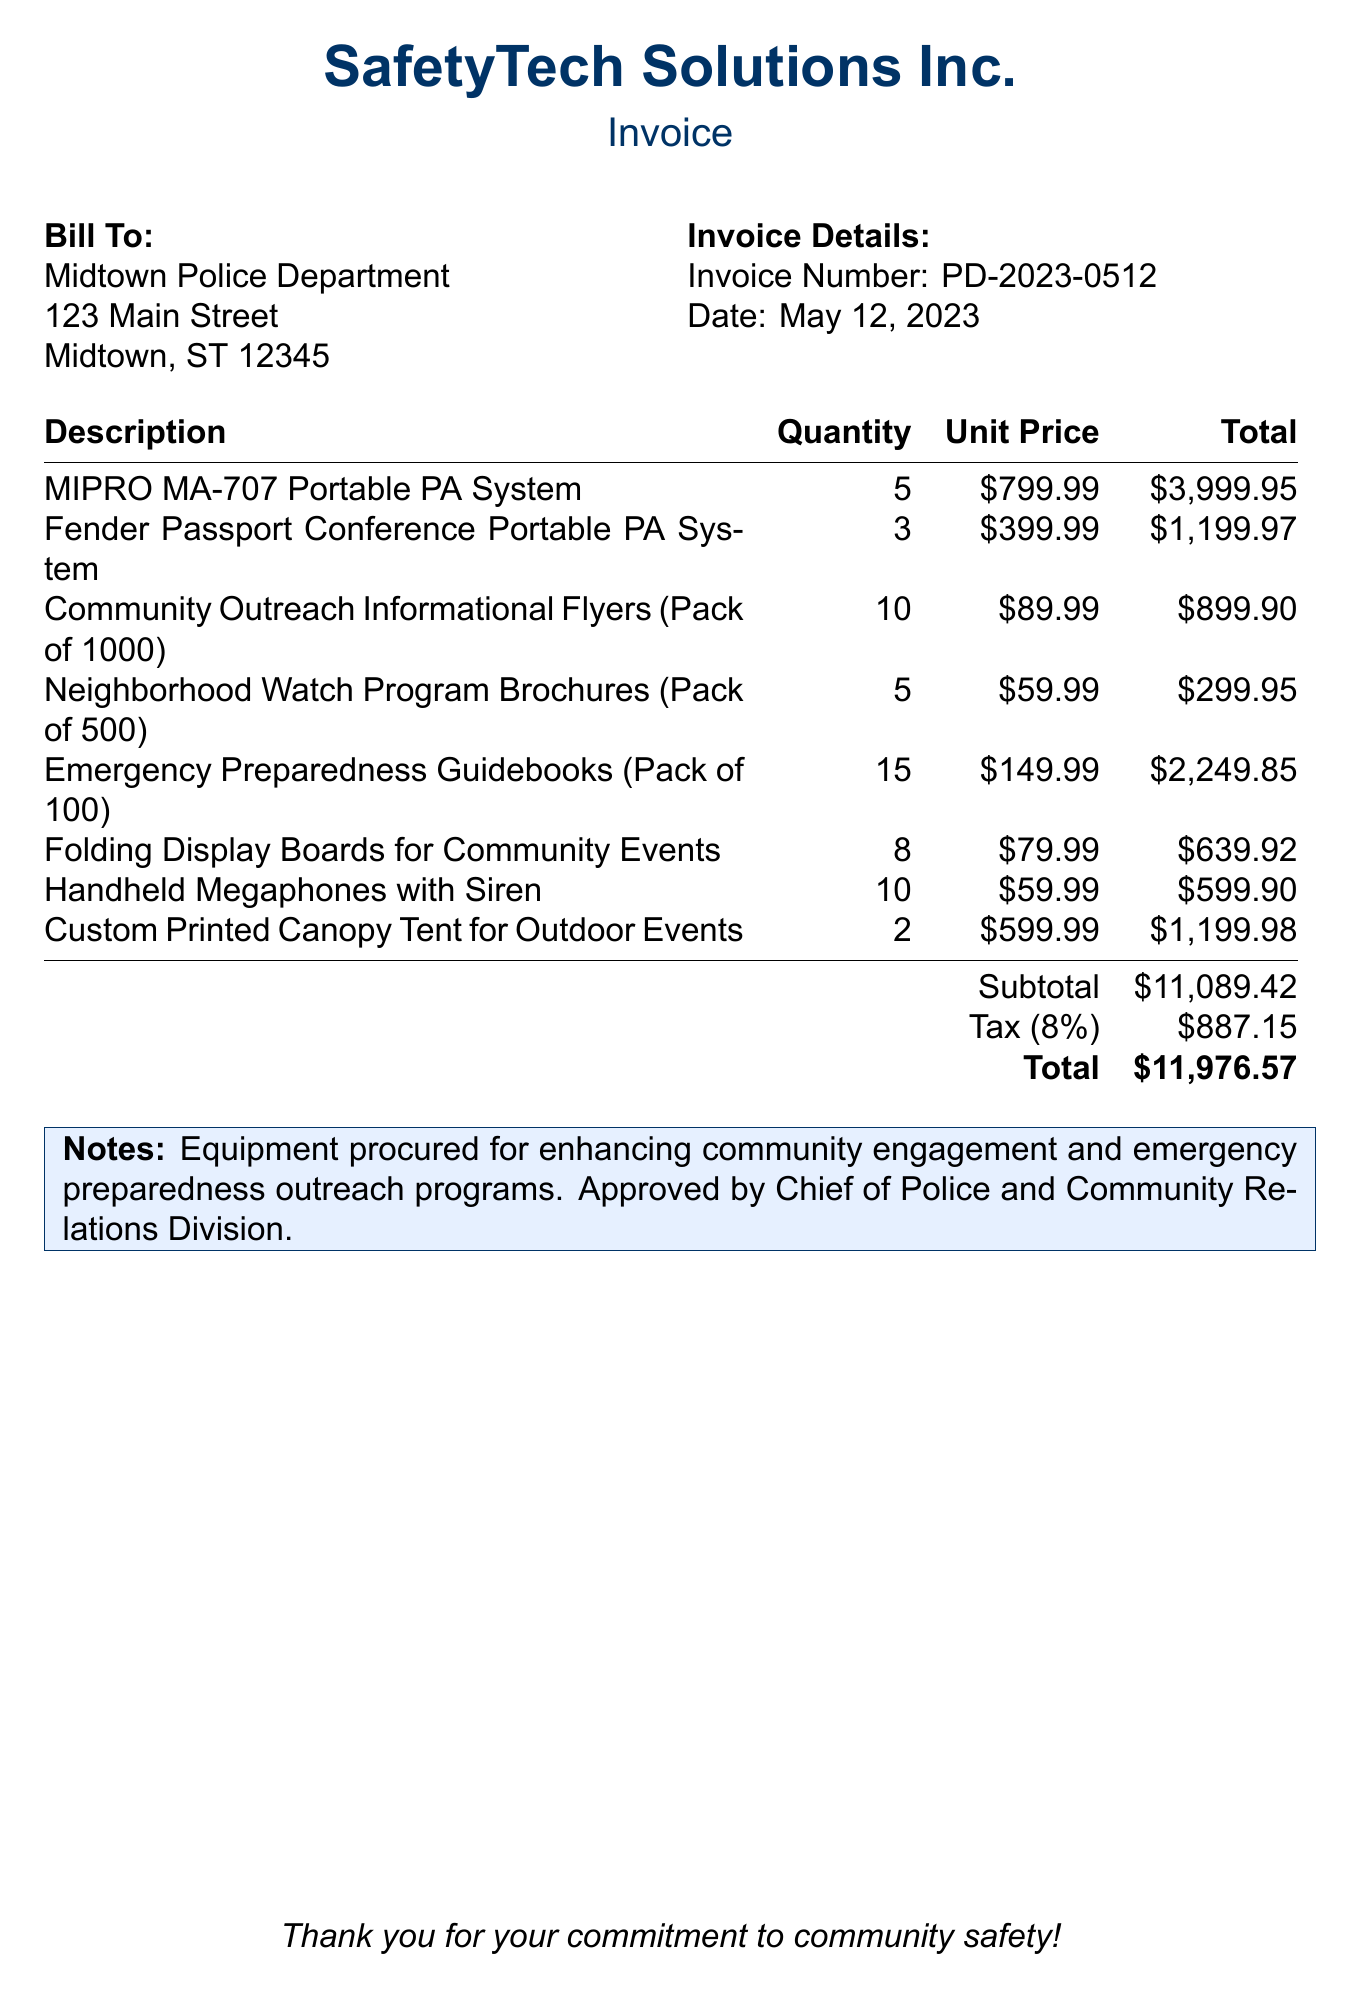What is the invoice number? The invoice number is explicitly listed in the document as PD-2023-0512.
Answer: PD-2023-0512 Who is the vendor? The vendor's name is indicated in the header of the invoice, which is SafetyTech Solutions Inc.
Answer: SafetyTech Solutions Inc What is the total amount due? The total amount due is summarized at the end of the invoice, which is $11,976.57.
Answer: $11,976.57 How many MIPRO MA-707 Portable PA Systems were purchased? The quantity of MIPRO MA-707 Portable PA Systems is specified in the items table.
Answer: 5 What is the subtotal before tax? The subtotal before tax is clearly stated in the document, which is $11,089.42.
Answer: $11,089.42 What is the tax rate applied? The tax rate is indicated in the tax section of the document, which is 8%.
Answer: 8% How many packs of Community Outreach Informational Flyers were ordered? The number of packs of Community Outreach Informational Flyers is detailed in the items list.
Answer: 10 What note is specified on the invoice? The note section contains a message about the purpose of the procurement, stating it is for enhancing community engagement and emergency preparedness outreach programs.
Answer: Equipment procured for enhancing community engagement and emergency preparedness outreach programs. Approved by Chief of Police and Community Relations Division 